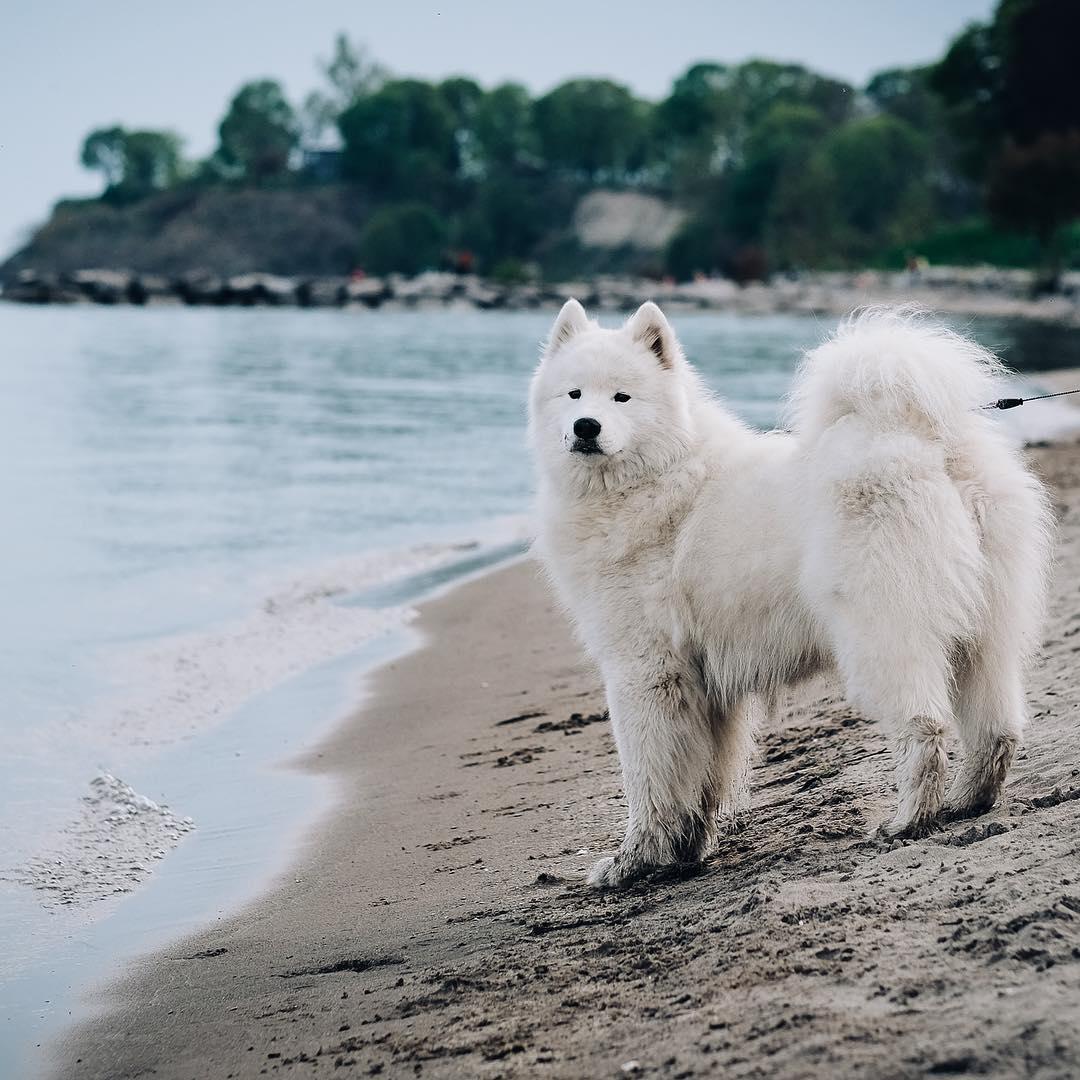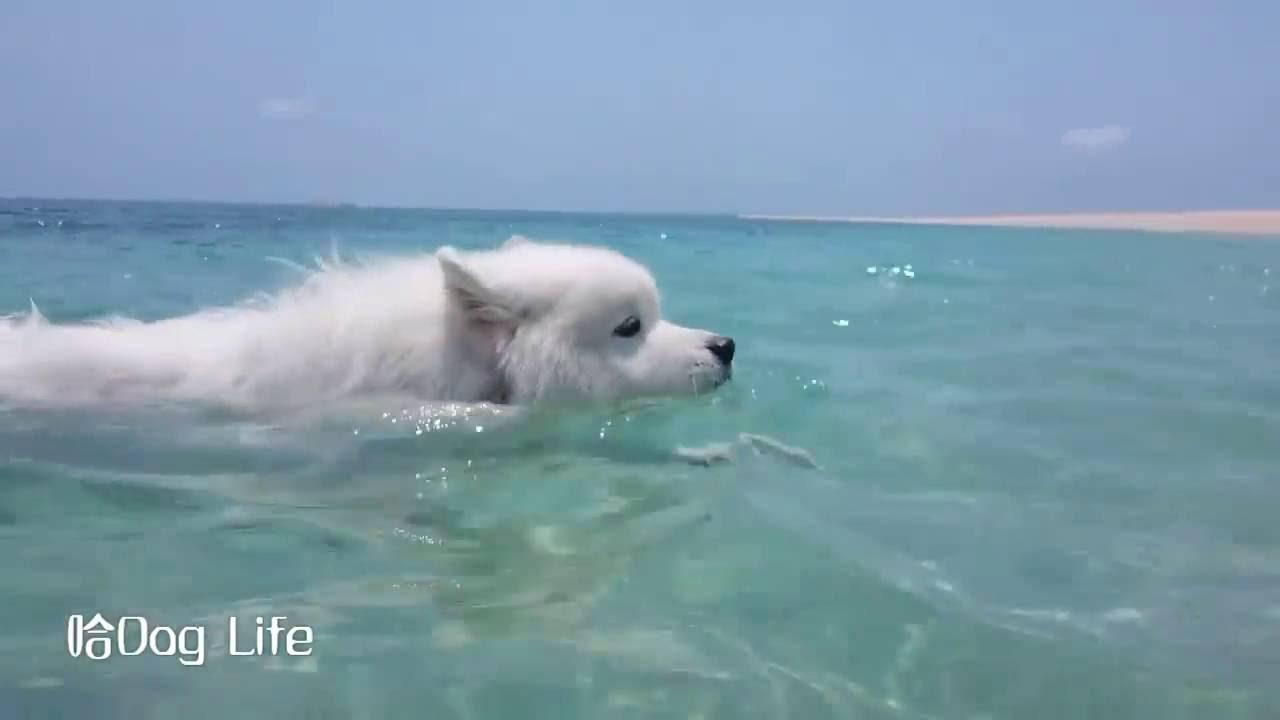The first image is the image on the left, the second image is the image on the right. Evaluate the accuracy of this statement regarding the images: "The dog in the left image is standing on the ground; he is not in the water.". Is it true? Answer yes or no. Yes. The first image is the image on the left, the second image is the image on the right. Assess this claim about the two images: "There is at least one dog that is not playing or swimming in the water.". Correct or not? Answer yes or no. Yes. 